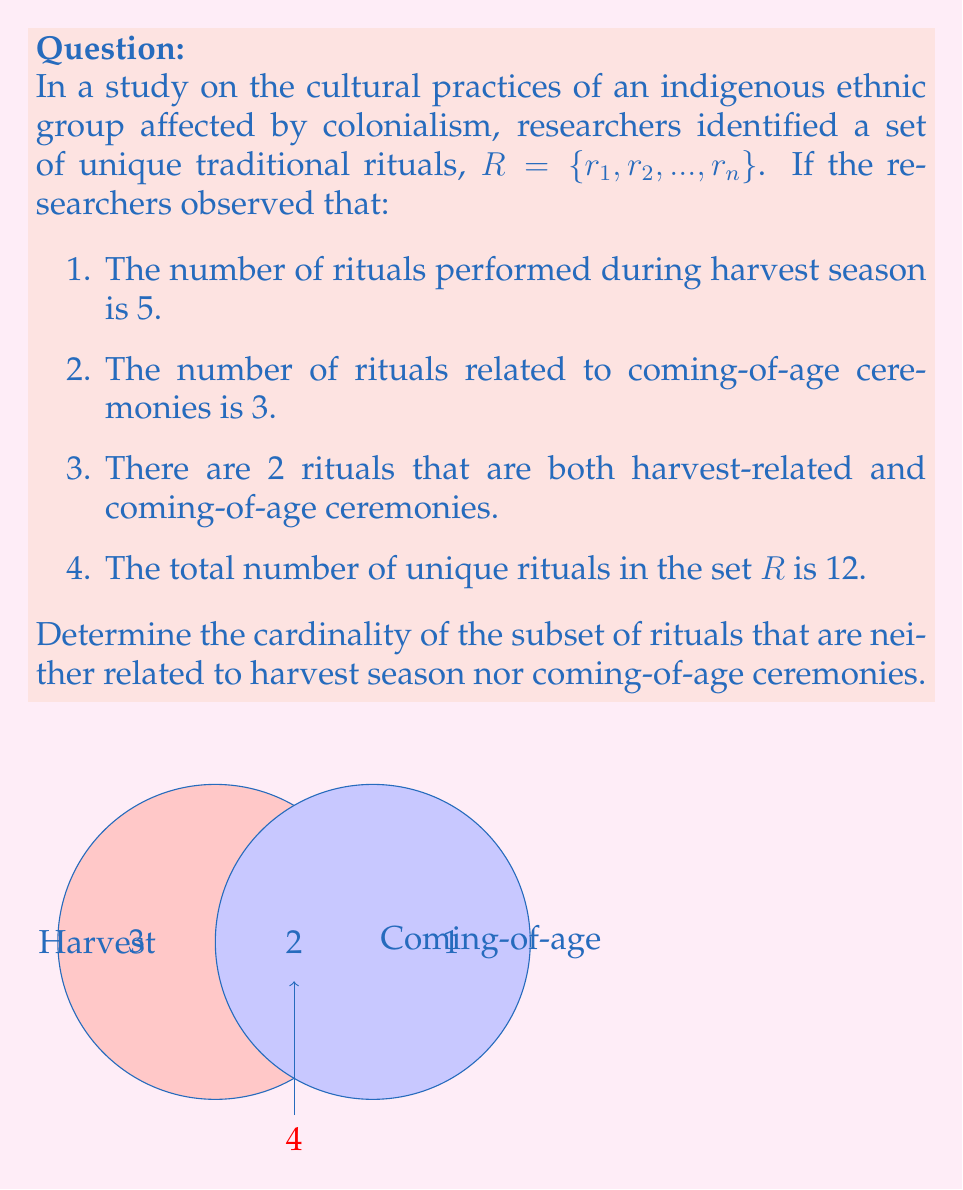What is the answer to this math problem? Let's approach this step-by-step using set theory:

1) Let H be the set of harvest rituals, and C be the set of coming-of-age rituals.

2) We're given:
   $|H| = 5$ (cardinality of H)
   $|C| = 3$ (cardinality of C)
   $|H \cap C| = 2$ (cardinality of the intersection)
   $|R| = 12$ (cardinality of the total set)

3) We can use the inclusion-exclusion principle to find $|H \cup C|$:
   $|H \cup C| = |H| + |C| - |H \cap C|$
   $|H \cup C| = 5 + 3 - 2 = 6$

4) Now, we can find the number of rituals that are neither harvest-related nor coming-of-age:
   $|R \setminus (H \cup C)| = |R| - |H \cup C|$
   $|R \setminus (H \cup C)| = 12 - 6 = 6$

Therefore, there are 6 rituals that are neither related to harvest season nor coming-of-age ceremonies.
Answer: 6 